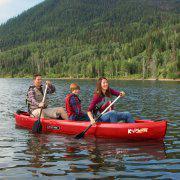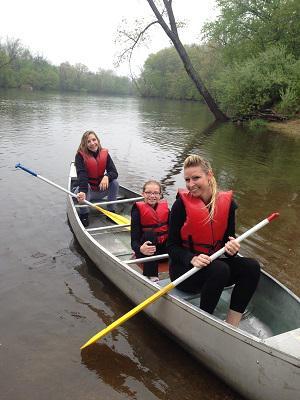The first image is the image on the left, the second image is the image on the right. For the images shown, is this caption "None of the boats are blue." true? Answer yes or no. Yes. The first image is the image on the left, the second image is the image on the right. For the images shown, is this caption "There is at most 1 dog in a canoe." true? Answer yes or no. No. 